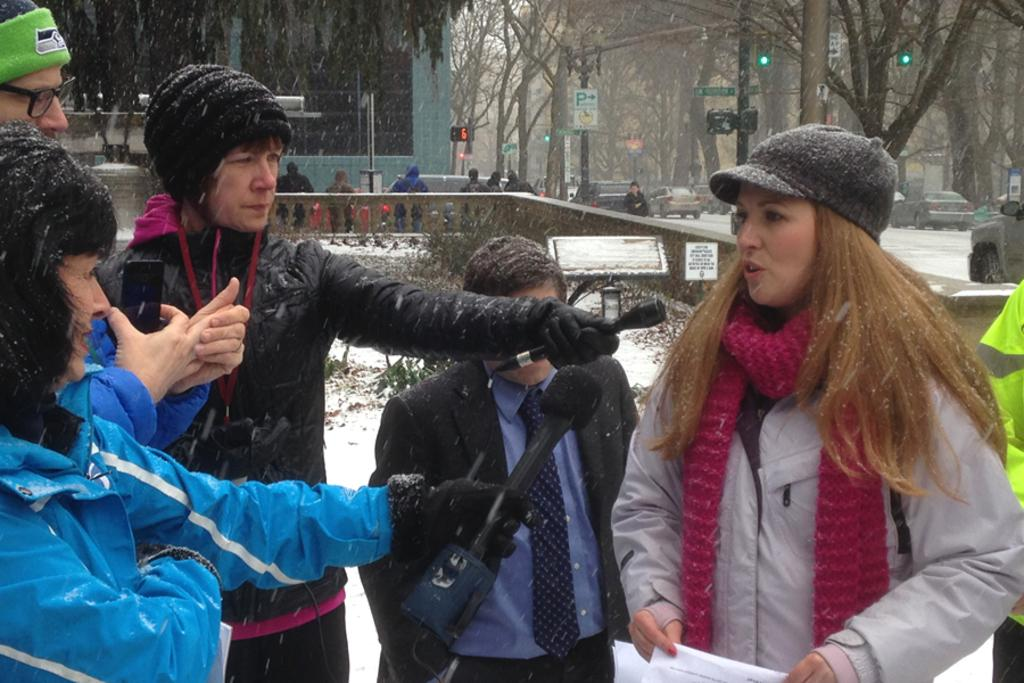How many people can be seen in the image? There are people in the image, but the exact number is not specified. What are some of the people doing in the image? Some people are carrying objects in the image. What type of structures are visible in the image? There are buildings in the image. What natural elements can be seen in the image? Trees and plants are present in the image. What man-made objects are visible in the image? Poles, lights, and vehicles are visible in the image. Are there any signs or notices in the image? Yes, there are boards with text in the image. What type of iron is being used to cook the oatmeal in the image? There is no iron or oatmeal present in the image. Can you see any sea creatures in the image? There is no sea or sea creatures present in the image. 